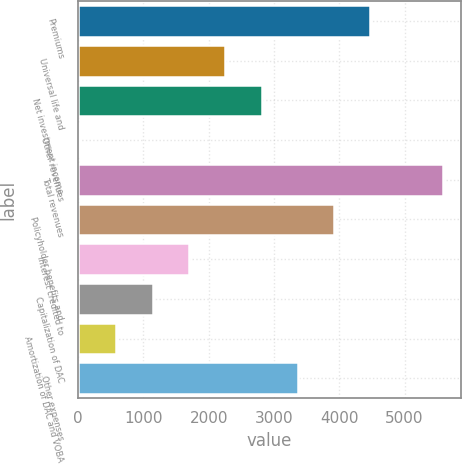<chart> <loc_0><loc_0><loc_500><loc_500><bar_chart><fcel>Premiums<fcel>Universal life and<fcel>Net investment income<fcel>Other revenues<fcel>Total revenues<fcel>Policyholder benefits and<fcel>Interest credited to<fcel>Capitalization of DAC<fcel>Amortization of DAC and VOBA<fcel>Other expenses<nl><fcel>4476.4<fcel>2255.2<fcel>2810.5<fcel>34<fcel>5587<fcel>3921.1<fcel>1699.9<fcel>1144.6<fcel>589.3<fcel>3365.8<nl></chart> 